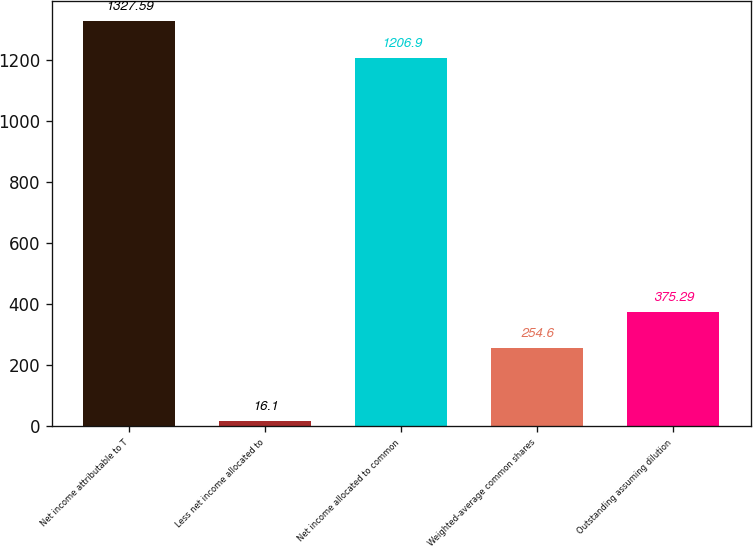Convert chart to OTSL. <chart><loc_0><loc_0><loc_500><loc_500><bar_chart><fcel>Net income attributable to T<fcel>Less net income allocated to<fcel>Net income allocated to common<fcel>Weighted-average common shares<fcel>Outstanding assuming dilution<nl><fcel>1327.59<fcel>16.1<fcel>1206.9<fcel>254.6<fcel>375.29<nl></chart> 